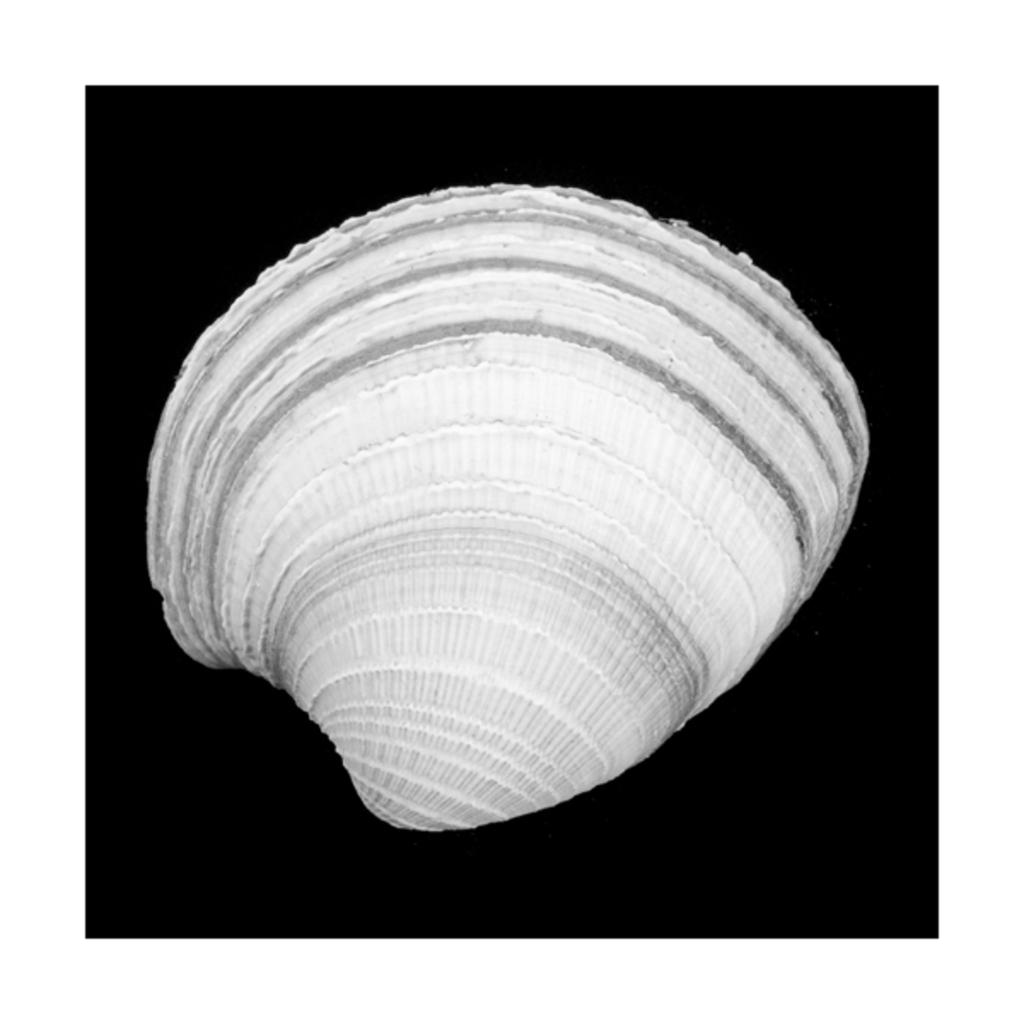What is the main subject of the image? The main subject of the image is a white-colored seashell. Can you describe the color of the seashell? The seashell is white in color. What color is present in the background of the image? The background of the image has a black color. What type of alley can be seen in the image? There is no alley present in the image; it features a white-colored seashell against a black background. How many quinces are visible in the image? There are no quinces present in the image; it only contains a white-colored seashell and a black background. 